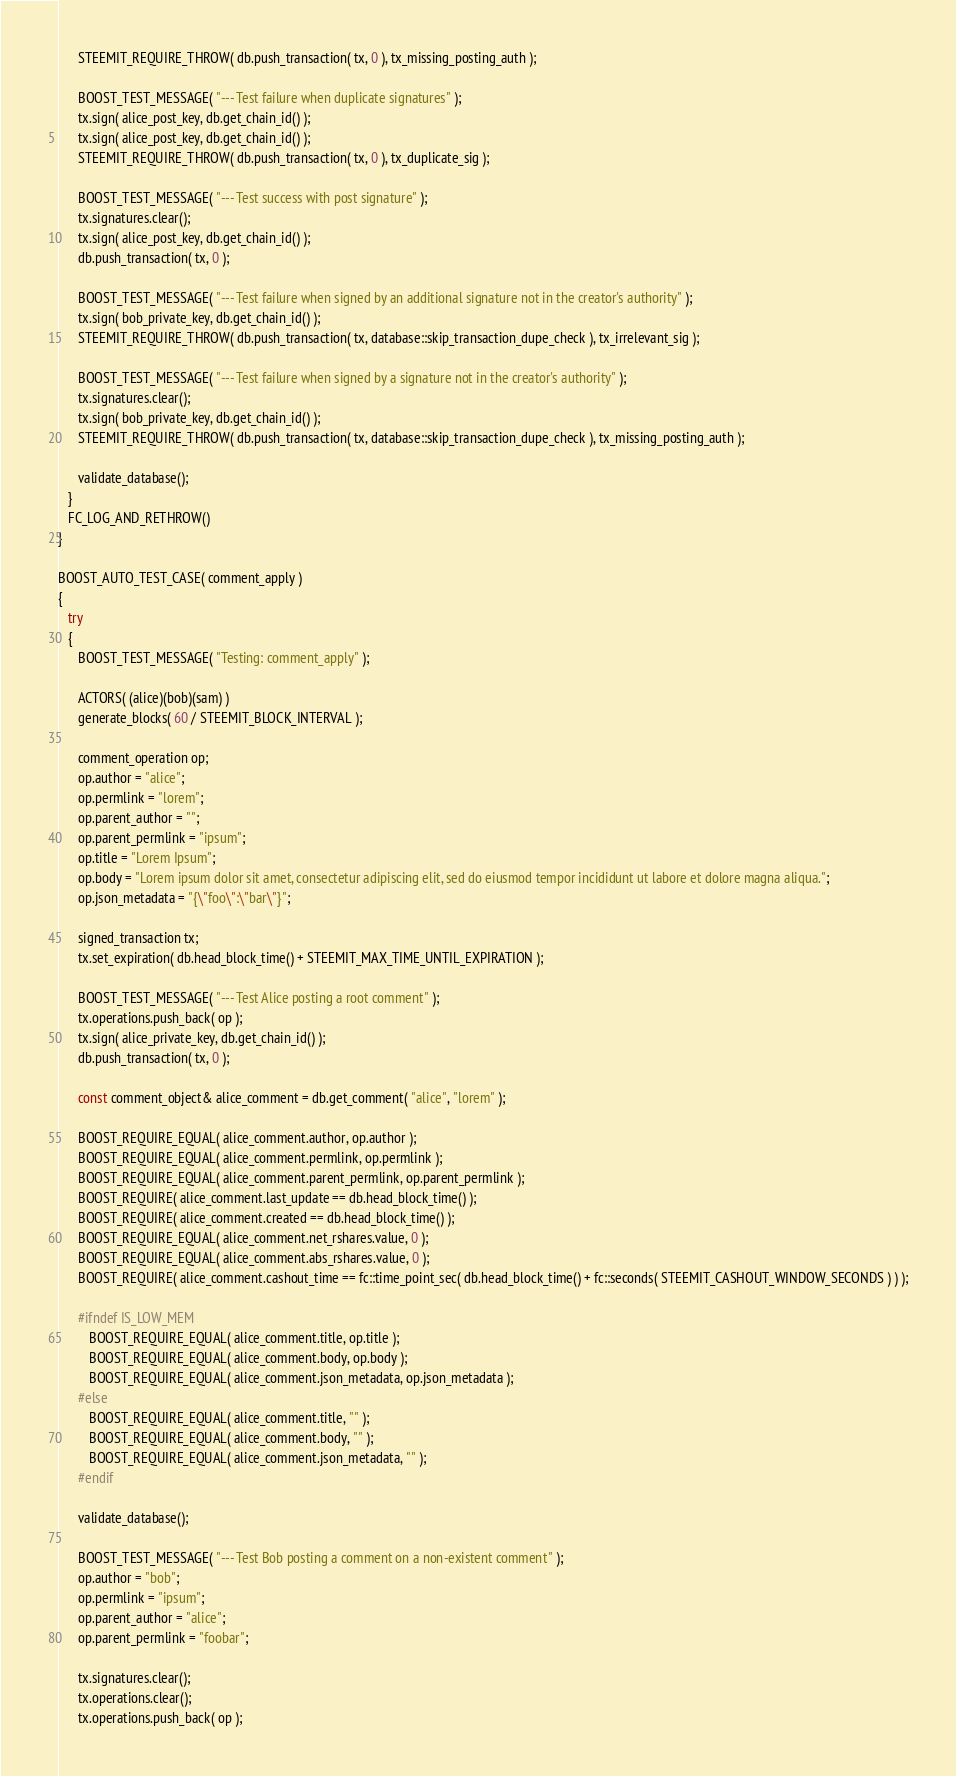<code> <loc_0><loc_0><loc_500><loc_500><_C++_>      STEEMIT_REQUIRE_THROW( db.push_transaction( tx, 0 ), tx_missing_posting_auth );

      BOOST_TEST_MESSAGE( "--- Test failure when duplicate signatures" );
      tx.sign( alice_post_key, db.get_chain_id() );
      tx.sign( alice_post_key, db.get_chain_id() );
      STEEMIT_REQUIRE_THROW( db.push_transaction( tx, 0 ), tx_duplicate_sig );

      BOOST_TEST_MESSAGE( "--- Test success with post signature" );
      tx.signatures.clear();
      tx.sign( alice_post_key, db.get_chain_id() );
      db.push_transaction( tx, 0 );

      BOOST_TEST_MESSAGE( "--- Test failure when signed by an additional signature not in the creator's authority" );
      tx.sign( bob_private_key, db.get_chain_id() );
      STEEMIT_REQUIRE_THROW( db.push_transaction( tx, database::skip_transaction_dupe_check ), tx_irrelevant_sig );

      BOOST_TEST_MESSAGE( "--- Test failure when signed by a signature not in the creator's authority" );
      tx.signatures.clear();
      tx.sign( bob_private_key, db.get_chain_id() );
      STEEMIT_REQUIRE_THROW( db.push_transaction( tx, database::skip_transaction_dupe_check ), tx_missing_posting_auth );

      validate_database();
   }
   FC_LOG_AND_RETHROW()
}

BOOST_AUTO_TEST_CASE( comment_apply )
{
   try
   {
      BOOST_TEST_MESSAGE( "Testing: comment_apply" );

      ACTORS( (alice)(bob)(sam) )
      generate_blocks( 60 / STEEMIT_BLOCK_INTERVAL );

      comment_operation op;
      op.author = "alice";
      op.permlink = "lorem";
      op.parent_author = "";
      op.parent_permlink = "ipsum";
      op.title = "Lorem Ipsum";
      op.body = "Lorem ipsum dolor sit amet, consectetur adipiscing elit, sed do eiusmod tempor incididunt ut labore et dolore magna aliqua.";
      op.json_metadata = "{\"foo\":\"bar\"}";

      signed_transaction tx;
      tx.set_expiration( db.head_block_time() + STEEMIT_MAX_TIME_UNTIL_EXPIRATION );

      BOOST_TEST_MESSAGE( "--- Test Alice posting a root comment" );
      tx.operations.push_back( op );
      tx.sign( alice_private_key, db.get_chain_id() );
      db.push_transaction( tx, 0 );

      const comment_object& alice_comment = db.get_comment( "alice", "lorem" );

      BOOST_REQUIRE_EQUAL( alice_comment.author, op.author );
      BOOST_REQUIRE_EQUAL( alice_comment.permlink, op.permlink );
      BOOST_REQUIRE_EQUAL( alice_comment.parent_permlink, op.parent_permlink );
      BOOST_REQUIRE( alice_comment.last_update == db.head_block_time() );
      BOOST_REQUIRE( alice_comment.created == db.head_block_time() );
      BOOST_REQUIRE_EQUAL( alice_comment.net_rshares.value, 0 );
      BOOST_REQUIRE_EQUAL( alice_comment.abs_rshares.value, 0 );
      BOOST_REQUIRE( alice_comment.cashout_time == fc::time_point_sec( db.head_block_time() + fc::seconds( STEEMIT_CASHOUT_WINDOW_SECONDS ) ) );

      #ifndef IS_LOW_MEM
         BOOST_REQUIRE_EQUAL( alice_comment.title, op.title );
         BOOST_REQUIRE_EQUAL( alice_comment.body, op.body );
         BOOST_REQUIRE_EQUAL( alice_comment.json_metadata, op.json_metadata );
      #else
         BOOST_REQUIRE_EQUAL( alice_comment.title, "" );
         BOOST_REQUIRE_EQUAL( alice_comment.body, "" );
         BOOST_REQUIRE_EQUAL( alice_comment.json_metadata, "" );
      #endif

      validate_database();

      BOOST_TEST_MESSAGE( "--- Test Bob posting a comment on a non-existent comment" );
      op.author = "bob";
      op.permlink = "ipsum";
      op.parent_author = "alice";
      op.parent_permlink = "foobar";

      tx.signatures.clear();
      tx.operations.clear();
      tx.operations.push_back( op );</code> 